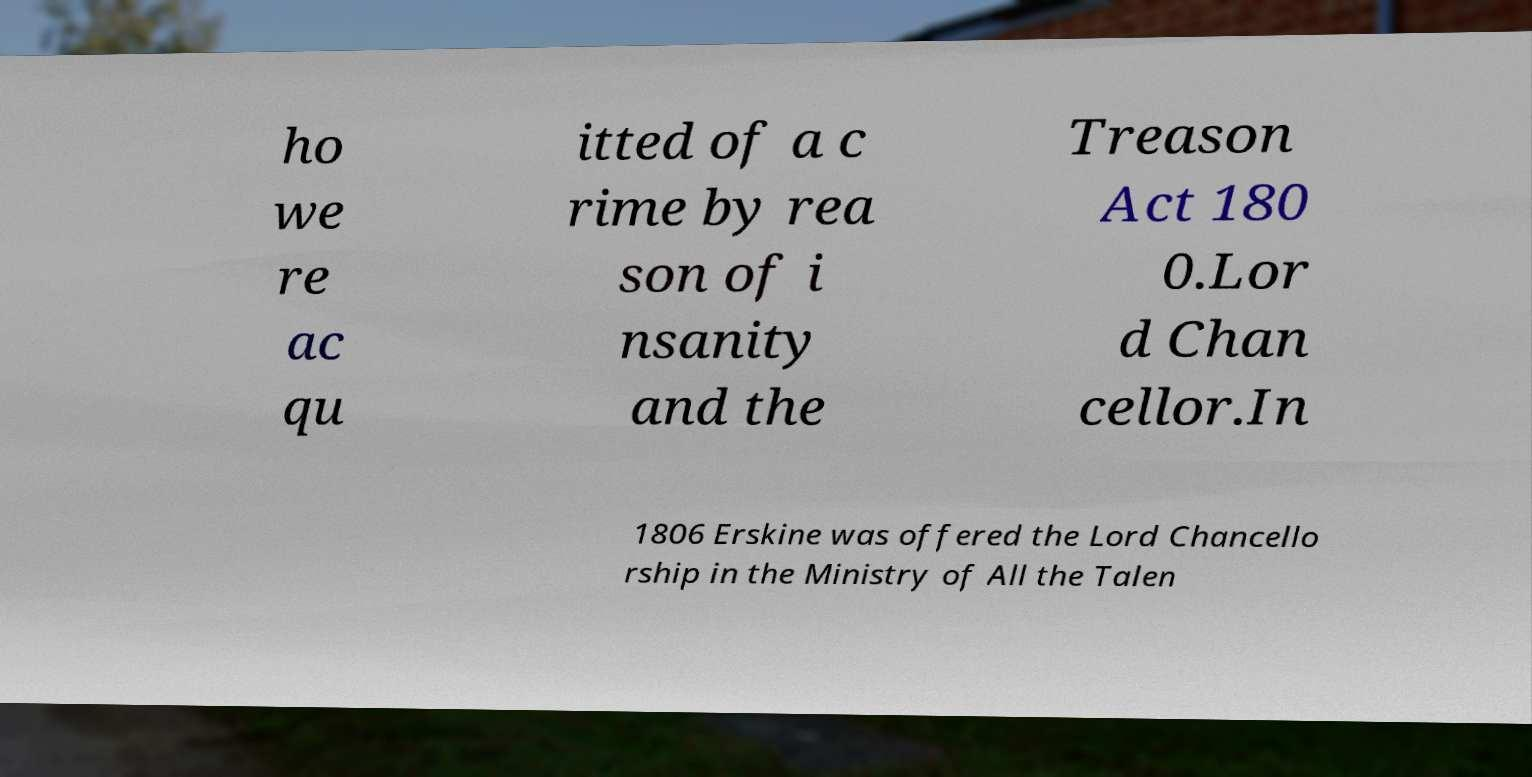Please read and relay the text visible in this image. What does it say? ho we re ac qu itted of a c rime by rea son of i nsanity and the Treason Act 180 0.Lor d Chan cellor.In 1806 Erskine was offered the Lord Chancello rship in the Ministry of All the Talen 